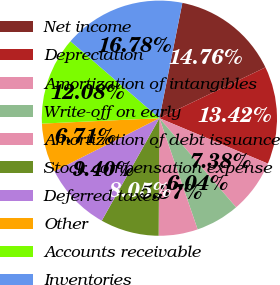Convert chart to OTSL. <chart><loc_0><loc_0><loc_500><loc_500><pie_chart><fcel>Net income<fcel>Depreciation<fcel>Amortization of intangibles<fcel>Write-off on early<fcel>Amortization of debt issuance<fcel>Stock compensation expense<fcel>Deferred taxes<fcel>Other<fcel>Accounts receivable<fcel>Inventories<nl><fcel>14.76%<fcel>13.42%<fcel>7.38%<fcel>6.04%<fcel>5.37%<fcel>8.05%<fcel>9.4%<fcel>6.71%<fcel>12.08%<fcel>16.78%<nl></chart> 